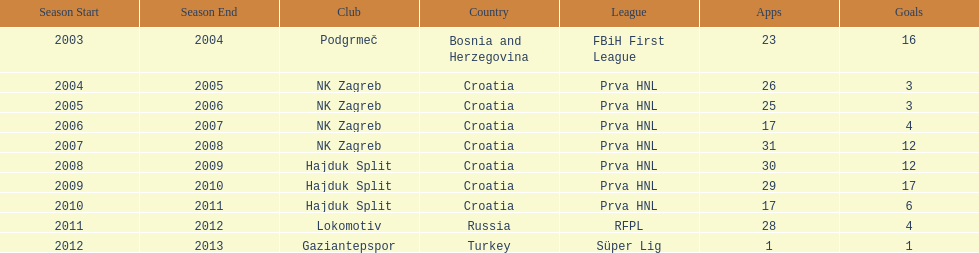Did ibricic score more or less goals in his 3 seasons with hajduk split when compared to his 4 seasons with nk zagreb? More. 